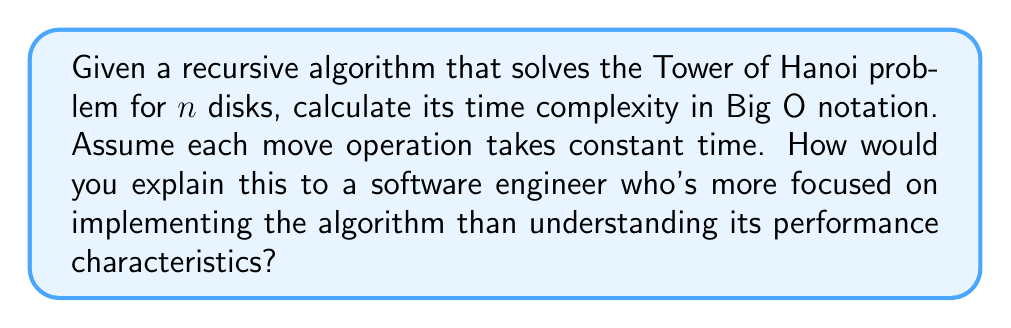Show me your answer to this math problem. Let's approach this step-by-step:

1) First, let's recall the recursive algorithm for Tower of Hanoi:
   
   ```
   function hanoi(n, source, auxiliary, target):
       if n == 1:
           move disk from source to target
       else:
           hanoi(n-1, source, target, auxiliary)
           move disk from source to target
           hanoi(n-1, auxiliary, source, target)
   ```

2) Now, let's analyze the number of moves:
   - For n = 1, we make 1 move
   - For n > 1, we make:
     * T(n-1) moves (first recursive call)
     * 1 move (moving the largest disk)
     * T(n-1) moves (second recursive call)

3) This gives us the recurrence relation:
   $$T(n) = 2T(n-1) + 1$$
   $$T(1) = 1$$

4) Let's expand this:
   $$T(n) = 2(2T(n-2) + 1) + 1 = 2^2T(n-2) + 2 + 1$$
   $$T(n) = 2^3T(n-3) + 2^2 + 2 + 1$$
   $$...$$
   $$T(n) = 2^{n-1}T(1) + 2^{n-2} + 2^{n-3} + ... + 2^2 + 2 + 1$$

5) Substituting T(1) = 1:
   $$T(n) = 2^{n-1} + 2^{n-2} + 2^{n-3} + ... + 2^2 + 2 + 1$$

6) This is a geometric series with first term 1 and common ratio 2. The sum of this series is:
   $$T(n) = 2^n - 1$$

7) In Big O notation, we ignore constant factors and lower order terms. Therefore:
   $$T(n) = O(2^n)$$

This exponential time complexity explains why the Tower of Hanoi problem becomes intractable for large n, despite its simple recursive implementation.
Answer: $O(2^n)$ 